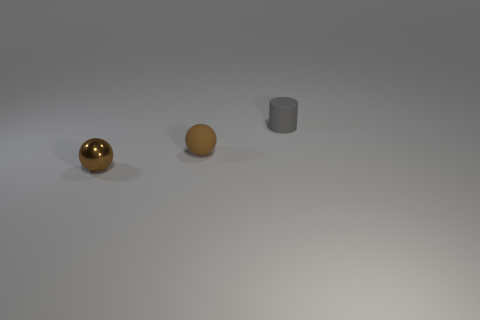What materials do the objects in the image appear to be made of? The objects in the image appear to be made of different materials. The sphere on the left has a reflective surface that indicates it might be made of metal, possibly gold or brass. The middle sphere has a matte finish and might be made of clay or plastic, given its orange-brownish color. The object on the right seems to have a smoother, perhaps metallic surface, suggesting it could be made of steel or aluminum. 